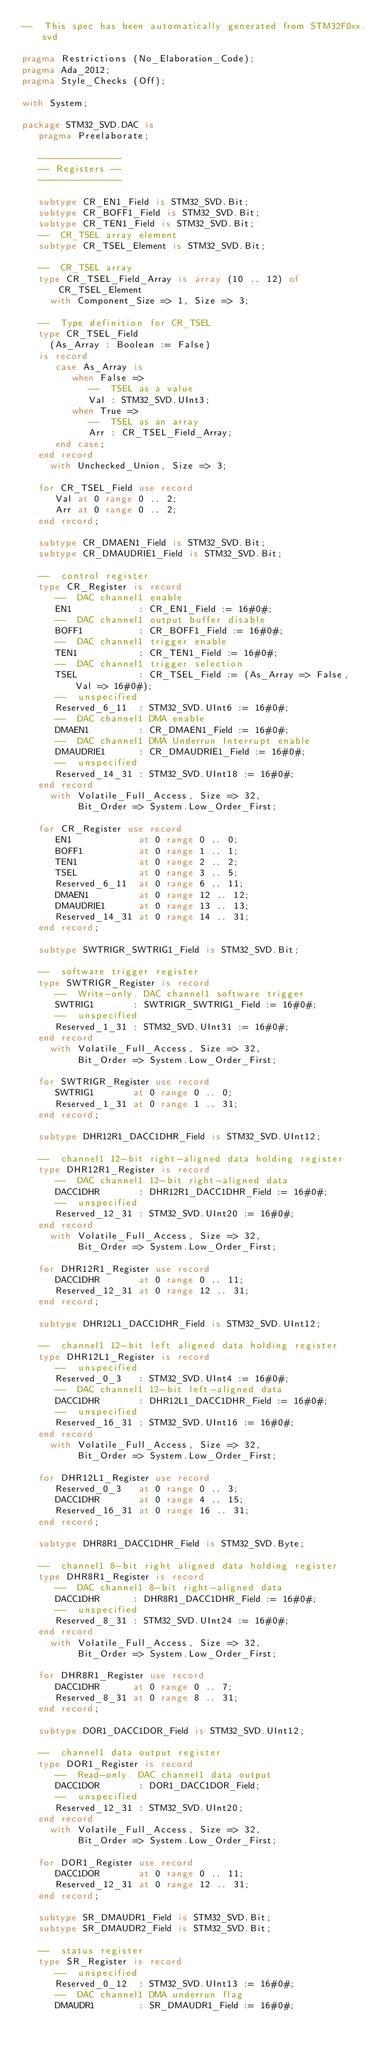<code> <loc_0><loc_0><loc_500><loc_500><_Ada_>--  This spec has been automatically generated from STM32F0xx.svd

pragma Restrictions (No_Elaboration_Code);
pragma Ada_2012;
pragma Style_Checks (Off);

with System;

package STM32_SVD.DAC is
   pragma Preelaborate;

   ---------------
   -- Registers --
   ---------------

   subtype CR_EN1_Field is STM32_SVD.Bit;
   subtype CR_BOFF1_Field is STM32_SVD.Bit;
   subtype CR_TEN1_Field is STM32_SVD.Bit;
   --  CR_TSEL array element
   subtype CR_TSEL_Element is STM32_SVD.Bit;

   --  CR_TSEL array
   type CR_TSEL_Field_Array is array (10 .. 12) of CR_TSEL_Element
     with Component_Size => 1, Size => 3;

   --  Type definition for CR_TSEL
   type CR_TSEL_Field
     (As_Array : Boolean := False)
   is record
      case As_Array is
         when False =>
            --  TSEL as a value
            Val : STM32_SVD.UInt3;
         when True =>
            --  TSEL as an array
            Arr : CR_TSEL_Field_Array;
      end case;
   end record
     with Unchecked_Union, Size => 3;

   for CR_TSEL_Field use record
      Val at 0 range 0 .. 2;
      Arr at 0 range 0 .. 2;
   end record;

   subtype CR_DMAEN1_Field is STM32_SVD.Bit;
   subtype CR_DMAUDRIE1_Field is STM32_SVD.Bit;

   --  control register
   type CR_Register is record
      --  DAC channel1 enable
      EN1            : CR_EN1_Field := 16#0#;
      --  DAC channel1 output buffer disable
      BOFF1          : CR_BOFF1_Field := 16#0#;
      --  DAC channel1 trigger enable
      TEN1           : CR_TEN1_Field := 16#0#;
      --  DAC channel1 trigger selection
      TSEL           : CR_TSEL_Field := (As_Array => False, Val => 16#0#);
      --  unspecified
      Reserved_6_11  : STM32_SVD.UInt6 := 16#0#;
      --  DAC channel1 DMA enable
      DMAEN1         : CR_DMAEN1_Field := 16#0#;
      --  DAC channel1 DMA Underrun Interrupt enable
      DMAUDRIE1      : CR_DMAUDRIE1_Field := 16#0#;
      --  unspecified
      Reserved_14_31 : STM32_SVD.UInt18 := 16#0#;
   end record
     with Volatile_Full_Access, Size => 32,
          Bit_Order => System.Low_Order_First;

   for CR_Register use record
      EN1            at 0 range 0 .. 0;
      BOFF1          at 0 range 1 .. 1;
      TEN1           at 0 range 2 .. 2;
      TSEL           at 0 range 3 .. 5;
      Reserved_6_11  at 0 range 6 .. 11;
      DMAEN1         at 0 range 12 .. 12;
      DMAUDRIE1      at 0 range 13 .. 13;
      Reserved_14_31 at 0 range 14 .. 31;
   end record;

   subtype SWTRIGR_SWTRIG1_Field is STM32_SVD.Bit;

   --  software trigger register
   type SWTRIGR_Register is record
      --  Write-only. DAC channel1 software trigger
      SWTRIG1       : SWTRIGR_SWTRIG1_Field := 16#0#;
      --  unspecified
      Reserved_1_31 : STM32_SVD.UInt31 := 16#0#;
   end record
     with Volatile_Full_Access, Size => 32,
          Bit_Order => System.Low_Order_First;

   for SWTRIGR_Register use record
      SWTRIG1       at 0 range 0 .. 0;
      Reserved_1_31 at 0 range 1 .. 31;
   end record;

   subtype DHR12R1_DACC1DHR_Field is STM32_SVD.UInt12;

   --  channel1 12-bit right-aligned data holding register
   type DHR12R1_Register is record
      --  DAC channel1 12-bit right-aligned data
      DACC1DHR       : DHR12R1_DACC1DHR_Field := 16#0#;
      --  unspecified
      Reserved_12_31 : STM32_SVD.UInt20 := 16#0#;
   end record
     with Volatile_Full_Access, Size => 32,
          Bit_Order => System.Low_Order_First;

   for DHR12R1_Register use record
      DACC1DHR       at 0 range 0 .. 11;
      Reserved_12_31 at 0 range 12 .. 31;
   end record;

   subtype DHR12L1_DACC1DHR_Field is STM32_SVD.UInt12;

   --  channel1 12-bit left aligned data holding register
   type DHR12L1_Register is record
      --  unspecified
      Reserved_0_3   : STM32_SVD.UInt4 := 16#0#;
      --  DAC channel1 12-bit left-aligned data
      DACC1DHR       : DHR12L1_DACC1DHR_Field := 16#0#;
      --  unspecified
      Reserved_16_31 : STM32_SVD.UInt16 := 16#0#;
   end record
     with Volatile_Full_Access, Size => 32,
          Bit_Order => System.Low_Order_First;

   for DHR12L1_Register use record
      Reserved_0_3   at 0 range 0 .. 3;
      DACC1DHR       at 0 range 4 .. 15;
      Reserved_16_31 at 0 range 16 .. 31;
   end record;

   subtype DHR8R1_DACC1DHR_Field is STM32_SVD.Byte;

   --  channel1 8-bit right aligned data holding register
   type DHR8R1_Register is record
      --  DAC channel1 8-bit right-aligned data
      DACC1DHR      : DHR8R1_DACC1DHR_Field := 16#0#;
      --  unspecified
      Reserved_8_31 : STM32_SVD.UInt24 := 16#0#;
   end record
     with Volatile_Full_Access, Size => 32,
          Bit_Order => System.Low_Order_First;

   for DHR8R1_Register use record
      DACC1DHR      at 0 range 0 .. 7;
      Reserved_8_31 at 0 range 8 .. 31;
   end record;

   subtype DOR1_DACC1DOR_Field is STM32_SVD.UInt12;

   --  channel1 data output register
   type DOR1_Register is record
      --  Read-only. DAC channel1 data output
      DACC1DOR       : DOR1_DACC1DOR_Field;
      --  unspecified
      Reserved_12_31 : STM32_SVD.UInt20;
   end record
     with Volatile_Full_Access, Size => 32,
          Bit_Order => System.Low_Order_First;

   for DOR1_Register use record
      DACC1DOR       at 0 range 0 .. 11;
      Reserved_12_31 at 0 range 12 .. 31;
   end record;

   subtype SR_DMAUDR1_Field is STM32_SVD.Bit;
   subtype SR_DMAUDR2_Field is STM32_SVD.Bit;

   --  status register
   type SR_Register is record
      --  unspecified
      Reserved_0_12  : STM32_SVD.UInt13 := 16#0#;
      --  DAC channel1 DMA underrun flag
      DMAUDR1        : SR_DMAUDR1_Field := 16#0#;</code> 